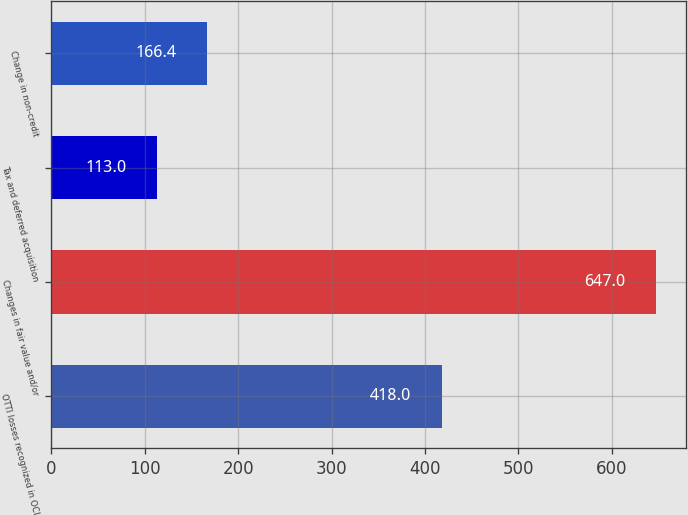Convert chart. <chart><loc_0><loc_0><loc_500><loc_500><bar_chart><fcel>OTTI losses recognized in OCI<fcel>Changes in fair value and/or<fcel>Tax and deferred acquisition<fcel>Change in non-credit<nl><fcel>418<fcel>647<fcel>113<fcel>166.4<nl></chart> 